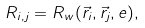Convert formula to latex. <formula><loc_0><loc_0><loc_500><loc_500>R _ { i , j } = R _ { w } ( \vec { r } _ { i } , \vec { r } _ { j } , e ) ,</formula> 